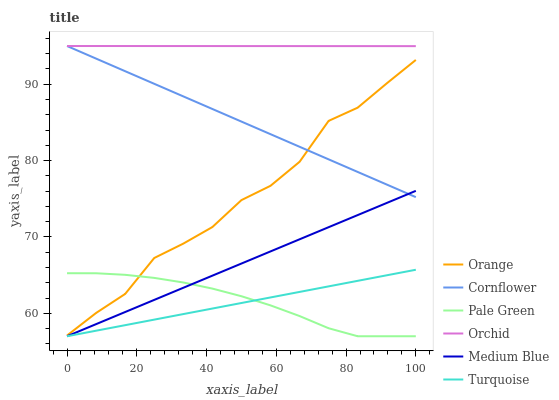Does Medium Blue have the minimum area under the curve?
Answer yes or no. No. Does Medium Blue have the maximum area under the curve?
Answer yes or no. No. Is Medium Blue the smoothest?
Answer yes or no. No. Is Medium Blue the roughest?
Answer yes or no. No. Does Orange have the lowest value?
Answer yes or no. No. Does Turquoise have the highest value?
Answer yes or no. No. Is Turquoise less than Orchid?
Answer yes or no. Yes. Is Orchid greater than Turquoise?
Answer yes or no. Yes. Does Turquoise intersect Orchid?
Answer yes or no. No. 